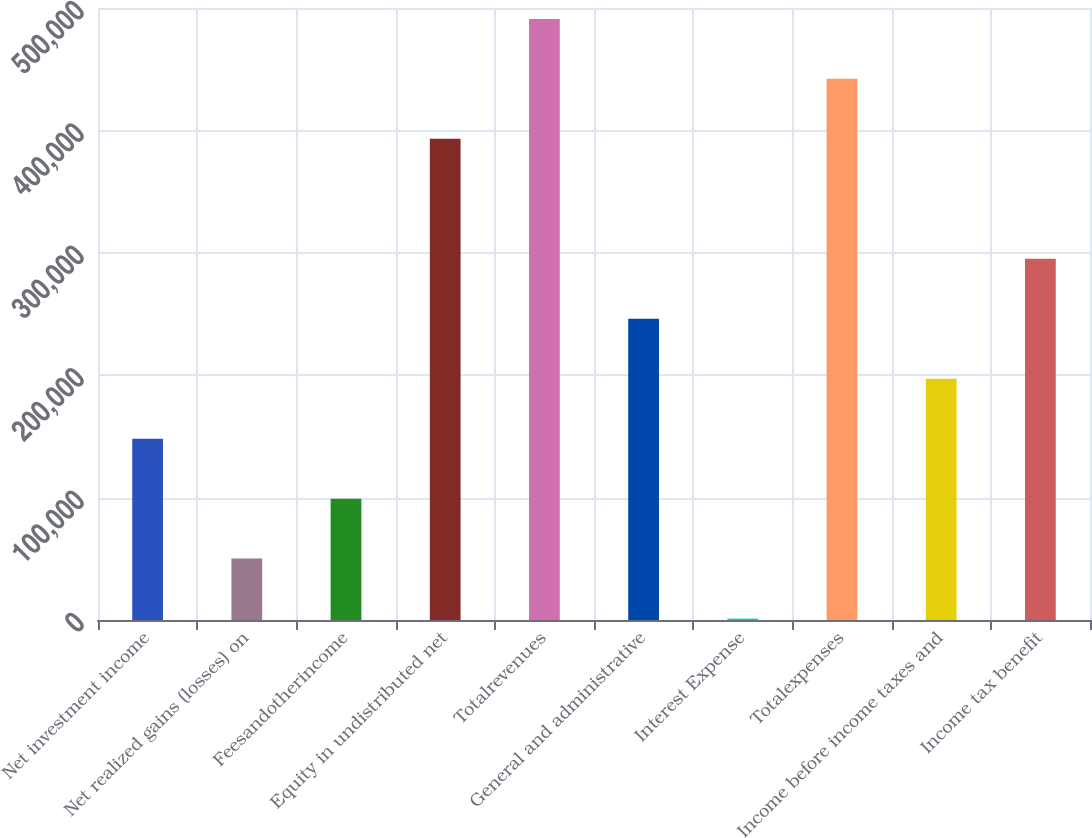Convert chart to OTSL. <chart><loc_0><loc_0><loc_500><loc_500><bar_chart><fcel>Net investment income<fcel>Net realized gains (losses) on<fcel>Feesandotherincome<fcel>Equity in undistributed net<fcel>Totalrevenues<fcel>General and administrative<fcel>Interest Expense<fcel>Totalexpenses<fcel>Income before income taxes and<fcel>Income tax benefit<nl><fcel>148152<fcel>50166.7<fcel>99159.4<fcel>393116<fcel>491101<fcel>246138<fcel>1174<fcel>442108<fcel>197145<fcel>295130<nl></chart> 